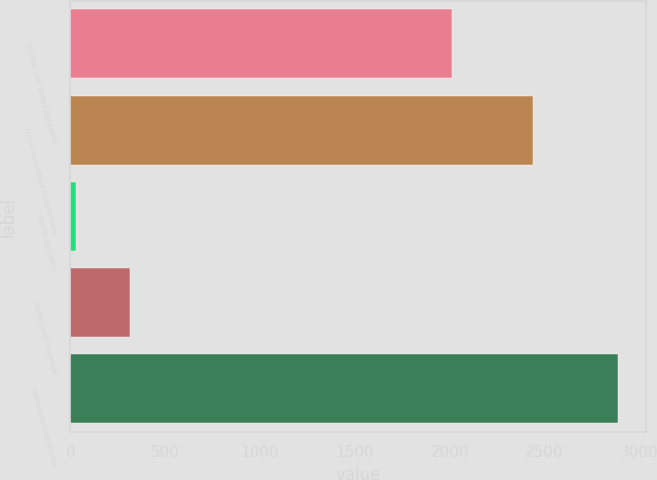Convert chart to OTSL. <chart><loc_0><loc_0><loc_500><loc_500><bar_chart><fcel>(for the year ended December<fcel>Gross investment income Fixed<fcel>Equity securities<fcel>Investment expenses<fcel>Net investment income<nl><fcel>2012<fcel>2439<fcel>28<fcel>314.1<fcel>2889<nl></chart> 